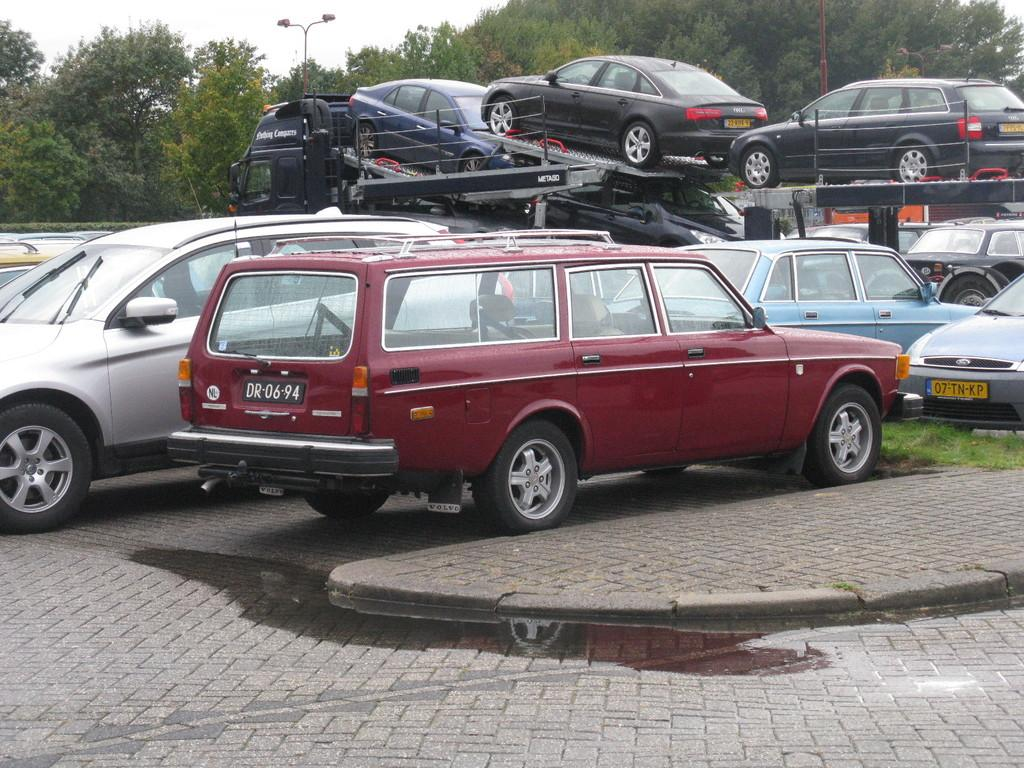What type of vehicles can be seen in the image? There are cars in the image. What type of vegetation is present in the image? There is grass in the image. What can be seen in the background of the image? There are trees and poles in the background of the image. What is visible in the sky in the image? The sky is visible in the background of the image. What type of reward is being given to the carriage in the image? There is no carriage present in the image, so there is no reward being given. 